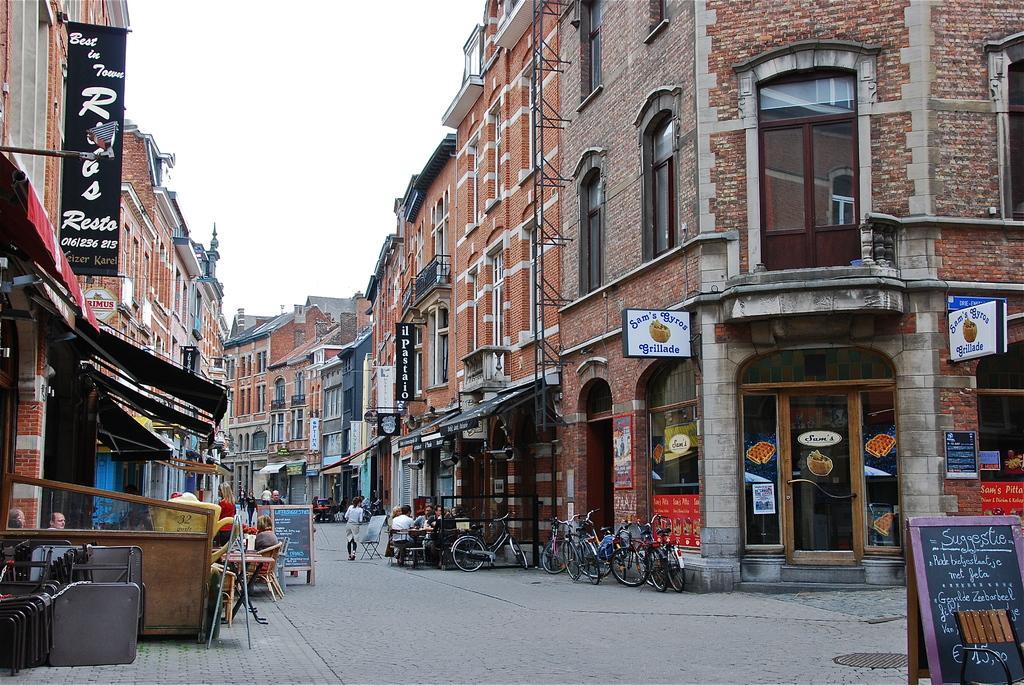Please provide a concise description of this image. In this image I can see few buildings, windows, doors, boards, banners, few bicycles, few people are sitting on the chairs. The sky is in white color. 